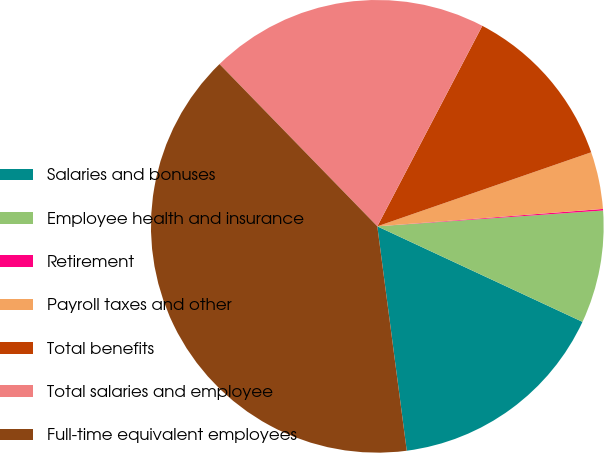Convert chart to OTSL. <chart><loc_0><loc_0><loc_500><loc_500><pie_chart><fcel>Salaries and bonuses<fcel>Employee health and insurance<fcel>Retirement<fcel>Payroll taxes and other<fcel>Total benefits<fcel>Total salaries and employee<fcel>Full-time equivalent employees<nl><fcel>15.99%<fcel>8.05%<fcel>0.11%<fcel>4.08%<fcel>12.02%<fcel>19.96%<fcel>39.8%<nl></chart> 